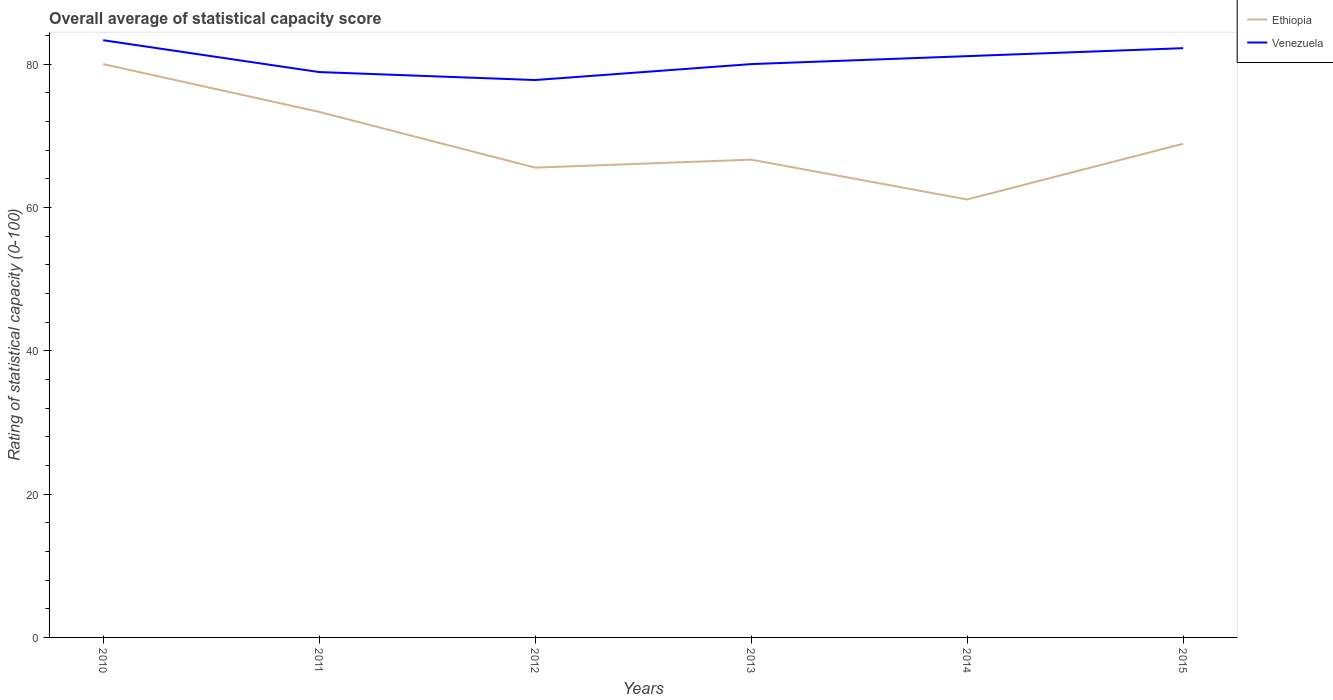Is the number of lines equal to the number of legend labels?
Offer a terse response. Yes. Across all years, what is the maximum rating of statistical capacity in Venezuela?
Provide a short and direct response. 77.78. In which year was the rating of statistical capacity in Ethiopia maximum?
Your answer should be compact. 2014. What is the total rating of statistical capacity in Ethiopia in the graph?
Offer a terse response. 12.22. What is the difference between the highest and the second highest rating of statistical capacity in Venezuela?
Provide a succinct answer. 5.56. How many lines are there?
Ensure brevity in your answer.  2. How many years are there in the graph?
Your answer should be compact. 6. What is the difference between two consecutive major ticks on the Y-axis?
Keep it short and to the point. 20. Are the values on the major ticks of Y-axis written in scientific E-notation?
Make the answer very short. No. How many legend labels are there?
Your response must be concise. 2. What is the title of the graph?
Provide a short and direct response. Overall average of statistical capacity score. Does "Kiribati" appear as one of the legend labels in the graph?
Your answer should be very brief. No. What is the label or title of the Y-axis?
Offer a very short reply. Rating of statistical capacity (0-100). What is the Rating of statistical capacity (0-100) in Ethiopia in 2010?
Your answer should be very brief. 80. What is the Rating of statistical capacity (0-100) of Venezuela in 2010?
Your answer should be very brief. 83.33. What is the Rating of statistical capacity (0-100) of Ethiopia in 2011?
Make the answer very short. 73.33. What is the Rating of statistical capacity (0-100) in Venezuela in 2011?
Your response must be concise. 78.89. What is the Rating of statistical capacity (0-100) in Ethiopia in 2012?
Offer a very short reply. 65.56. What is the Rating of statistical capacity (0-100) of Venezuela in 2012?
Provide a short and direct response. 77.78. What is the Rating of statistical capacity (0-100) in Ethiopia in 2013?
Make the answer very short. 66.67. What is the Rating of statistical capacity (0-100) in Venezuela in 2013?
Provide a short and direct response. 80. What is the Rating of statistical capacity (0-100) of Ethiopia in 2014?
Offer a very short reply. 61.11. What is the Rating of statistical capacity (0-100) in Venezuela in 2014?
Your answer should be very brief. 81.11. What is the Rating of statistical capacity (0-100) in Ethiopia in 2015?
Offer a terse response. 68.89. What is the Rating of statistical capacity (0-100) of Venezuela in 2015?
Offer a terse response. 82.22. Across all years, what is the maximum Rating of statistical capacity (0-100) in Venezuela?
Offer a terse response. 83.33. Across all years, what is the minimum Rating of statistical capacity (0-100) of Ethiopia?
Offer a very short reply. 61.11. Across all years, what is the minimum Rating of statistical capacity (0-100) of Venezuela?
Offer a very short reply. 77.78. What is the total Rating of statistical capacity (0-100) of Ethiopia in the graph?
Offer a very short reply. 415.56. What is the total Rating of statistical capacity (0-100) in Venezuela in the graph?
Make the answer very short. 483.33. What is the difference between the Rating of statistical capacity (0-100) in Ethiopia in 2010 and that in 2011?
Provide a succinct answer. 6.67. What is the difference between the Rating of statistical capacity (0-100) of Venezuela in 2010 and that in 2011?
Offer a terse response. 4.44. What is the difference between the Rating of statistical capacity (0-100) in Ethiopia in 2010 and that in 2012?
Give a very brief answer. 14.44. What is the difference between the Rating of statistical capacity (0-100) in Venezuela in 2010 and that in 2012?
Your answer should be compact. 5.56. What is the difference between the Rating of statistical capacity (0-100) of Ethiopia in 2010 and that in 2013?
Your answer should be very brief. 13.33. What is the difference between the Rating of statistical capacity (0-100) in Venezuela in 2010 and that in 2013?
Provide a short and direct response. 3.33. What is the difference between the Rating of statistical capacity (0-100) of Ethiopia in 2010 and that in 2014?
Provide a succinct answer. 18.89. What is the difference between the Rating of statistical capacity (0-100) in Venezuela in 2010 and that in 2014?
Ensure brevity in your answer.  2.22. What is the difference between the Rating of statistical capacity (0-100) in Ethiopia in 2010 and that in 2015?
Your answer should be compact. 11.11. What is the difference between the Rating of statistical capacity (0-100) of Ethiopia in 2011 and that in 2012?
Offer a terse response. 7.78. What is the difference between the Rating of statistical capacity (0-100) in Venezuela in 2011 and that in 2012?
Your response must be concise. 1.11. What is the difference between the Rating of statistical capacity (0-100) in Ethiopia in 2011 and that in 2013?
Your answer should be very brief. 6.67. What is the difference between the Rating of statistical capacity (0-100) in Venezuela in 2011 and that in 2013?
Offer a very short reply. -1.11. What is the difference between the Rating of statistical capacity (0-100) of Ethiopia in 2011 and that in 2014?
Your response must be concise. 12.22. What is the difference between the Rating of statistical capacity (0-100) in Venezuela in 2011 and that in 2014?
Your response must be concise. -2.22. What is the difference between the Rating of statistical capacity (0-100) of Ethiopia in 2011 and that in 2015?
Give a very brief answer. 4.44. What is the difference between the Rating of statistical capacity (0-100) of Venezuela in 2011 and that in 2015?
Ensure brevity in your answer.  -3.33. What is the difference between the Rating of statistical capacity (0-100) in Ethiopia in 2012 and that in 2013?
Offer a terse response. -1.11. What is the difference between the Rating of statistical capacity (0-100) in Venezuela in 2012 and that in 2013?
Your response must be concise. -2.22. What is the difference between the Rating of statistical capacity (0-100) of Ethiopia in 2012 and that in 2014?
Provide a short and direct response. 4.44. What is the difference between the Rating of statistical capacity (0-100) of Ethiopia in 2012 and that in 2015?
Provide a succinct answer. -3.33. What is the difference between the Rating of statistical capacity (0-100) in Venezuela in 2012 and that in 2015?
Make the answer very short. -4.44. What is the difference between the Rating of statistical capacity (0-100) of Ethiopia in 2013 and that in 2014?
Offer a very short reply. 5.56. What is the difference between the Rating of statistical capacity (0-100) of Venezuela in 2013 and that in 2014?
Your answer should be compact. -1.11. What is the difference between the Rating of statistical capacity (0-100) in Ethiopia in 2013 and that in 2015?
Your response must be concise. -2.22. What is the difference between the Rating of statistical capacity (0-100) in Venezuela in 2013 and that in 2015?
Provide a succinct answer. -2.22. What is the difference between the Rating of statistical capacity (0-100) of Ethiopia in 2014 and that in 2015?
Provide a succinct answer. -7.78. What is the difference between the Rating of statistical capacity (0-100) in Venezuela in 2014 and that in 2015?
Provide a succinct answer. -1.11. What is the difference between the Rating of statistical capacity (0-100) of Ethiopia in 2010 and the Rating of statistical capacity (0-100) of Venezuela in 2011?
Your answer should be very brief. 1.11. What is the difference between the Rating of statistical capacity (0-100) in Ethiopia in 2010 and the Rating of statistical capacity (0-100) in Venezuela in 2012?
Give a very brief answer. 2.22. What is the difference between the Rating of statistical capacity (0-100) in Ethiopia in 2010 and the Rating of statistical capacity (0-100) in Venezuela in 2014?
Provide a succinct answer. -1.11. What is the difference between the Rating of statistical capacity (0-100) in Ethiopia in 2010 and the Rating of statistical capacity (0-100) in Venezuela in 2015?
Ensure brevity in your answer.  -2.22. What is the difference between the Rating of statistical capacity (0-100) of Ethiopia in 2011 and the Rating of statistical capacity (0-100) of Venezuela in 2012?
Offer a terse response. -4.44. What is the difference between the Rating of statistical capacity (0-100) in Ethiopia in 2011 and the Rating of statistical capacity (0-100) in Venezuela in 2013?
Offer a terse response. -6.67. What is the difference between the Rating of statistical capacity (0-100) of Ethiopia in 2011 and the Rating of statistical capacity (0-100) of Venezuela in 2014?
Offer a very short reply. -7.78. What is the difference between the Rating of statistical capacity (0-100) of Ethiopia in 2011 and the Rating of statistical capacity (0-100) of Venezuela in 2015?
Your answer should be compact. -8.89. What is the difference between the Rating of statistical capacity (0-100) of Ethiopia in 2012 and the Rating of statistical capacity (0-100) of Venezuela in 2013?
Make the answer very short. -14.44. What is the difference between the Rating of statistical capacity (0-100) in Ethiopia in 2012 and the Rating of statistical capacity (0-100) in Venezuela in 2014?
Your answer should be compact. -15.56. What is the difference between the Rating of statistical capacity (0-100) in Ethiopia in 2012 and the Rating of statistical capacity (0-100) in Venezuela in 2015?
Your answer should be compact. -16.67. What is the difference between the Rating of statistical capacity (0-100) in Ethiopia in 2013 and the Rating of statistical capacity (0-100) in Venezuela in 2014?
Offer a terse response. -14.44. What is the difference between the Rating of statistical capacity (0-100) of Ethiopia in 2013 and the Rating of statistical capacity (0-100) of Venezuela in 2015?
Provide a succinct answer. -15.56. What is the difference between the Rating of statistical capacity (0-100) in Ethiopia in 2014 and the Rating of statistical capacity (0-100) in Venezuela in 2015?
Offer a very short reply. -21.11. What is the average Rating of statistical capacity (0-100) of Ethiopia per year?
Your response must be concise. 69.26. What is the average Rating of statistical capacity (0-100) of Venezuela per year?
Your answer should be very brief. 80.56. In the year 2011, what is the difference between the Rating of statistical capacity (0-100) in Ethiopia and Rating of statistical capacity (0-100) in Venezuela?
Offer a very short reply. -5.56. In the year 2012, what is the difference between the Rating of statistical capacity (0-100) of Ethiopia and Rating of statistical capacity (0-100) of Venezuela?
Ensure brevity in your answer.  -12.22. In the year 2013, what is the difference between the Rating of statistical capacity (0-100) in Ethiopia and Rating of statistical capacity (0-100) in Venezuela?
Offer a very short reply. -13.33. In the year 2014, what is the difference between the Rating of statistical capacity (0-100) of Ethiopia and Rating of statistical capacity (0-100) of Venezuela?
Give a very brief answer. -20. In the year 2015, what is the difference between the Rating of statistical capacity (0-100) in Ethiopia and Rating of statistical capacity (0-100) in Venezuela?
Your answer should be very brief. -13.33. What is the ratio of the Rating of statistical capacity (0-100) of Venezuela in 2010 to that in 2011?
Make the answer very short. 1.06. What is the ratio of the Rating of statistical capacity (0-100) of Ethiopia in 2010 to that in 2012?
Offer a very short reply. 1.22. What is the ratio of the Rating of statistical capacity (0-100) of Venezuela in 2010 to that in 2012?
Make the answer very short. 1.07. What is the ratio of the Rating of statistical capacity (0-100) in Ethiopia in 2010 to that in 2013?
Give a very brief answer. 1.2. What is the ratio of the Rating of statistical capacity (0-100) of Venezuela in 2010 to that in 2013?
Your answer should be very brief. 1.04. What is the ratio of the Rating of statistical capacity (0-100) in Ethiopia in 2010 to that in 2014?
Provide a succinct answer. 1.31. What is the ratio of the Rating of statistical capacity (0-100) of Venezuela in 2010 to that in 2014?
Your response must be concise. 1.03. What is the ratio of the Rating of statistical capacity (0-100) in Ethiopia in 2010 to that in 2015?
Your answer should be compact. 1.16. What is the ratio of the Rating of statistical capacity (0-100) in Venezuela in 2010 to that in 2015?
Provide a succinct answer. 1.01. What is the ratio of the Rating of statistical capacity (0-100) in Ethiopia in 2011 to that in 2012?
Provide a short and direct response. 1.12. What is the ratio of the Rating of statistical capacity (0-100) of Venezuela in 2011 to that in 2012?
Make the answer very short. 1.01. What is the ratio of the Rating of statistical capacity (0-100) of Venezuela in 2011 to that in 2013?
Provide a short and direct response. 0.99. What is the ratio of the Rating of statistical capacity (0-100) in Ethiopia in 2011 to that in 2014?
Ensure brevity in your answer.  1.2. What is the ratio of the Rating of statistical capacity (0-100) of Venezuela in 2011 to that in 2014?
Give a very brief answer. 0.97. What is the ratio of the Rating of statistical capacity (0-100) in Ethiopia in 2011 to that in 2015?
Provide a short and direct response. 1.06. What is the ratio of the Rating of statistical capacity (0-100) of Venezuela in 2011 to that in 2015?
Make the answer very short. 0.96. What is the ratio of the Rating of statistical capacity (0-100) of Ethiopia in 2012 to that in 2013?
Offer a terse response. 0.98. What is the ratio of the Rating of statistical capacity (0-100) of Venezuela in 2012 to that in 2013?
Give a very brief answer. 0.97. What is the ratio of the Rating of statistical capacity (0-100) in Ethiopia in 2012 to that in 2014?
Ensure brevity in your answer.  1.07. What is the ratio of the Rating of statistical capacity (0-100) of Venezuela in 2012 to that in 2014?
Offer a terse response. 0.96. What is the ratio of the Rating of statistical capacity (0-100) in Ethiopia in 2012 to that in 2015?
Ensure brevity in your answer.  0.95. What is the ratio of the Rating of statistical capacity (0-100) in Venezuela in 2012 to that in 2015?
Offer a terse response. 0.95. What is the ratio of the Rating of statistical capacity (0-100) in Ethiopia in 2013 to that in 2014?
Your response must be concise. 1.09. What is the ratio of the Rating of statistical capacity (0-100) of Venezuela in 2013 to that in 2014?
Your answer should be compact. 0.99. What is the ratio of the Rating of statistical capacity (0-100) in Ethiopia in 2014 to that in 2015?
Your response must be concise. 0.89. What is the ratio of the Rating of statistical capacity (0-100) in Venezuela in 2014 to that in 2015?
Your answer should be compact. 0.99. What is the difference between the highest and the second highest Rating of statistical capacity (0-100) in Venezuela?
Your response must be concise. 1.11. What is the difference between the highest and the lowest Rating of statistical capacity (0-100) of Ethiopia?
Give a very brief answer. 18.89. What is the difference between the highest and the lowest Rating of statistical capacity (0-100) in Venezuela?
Your answer should be compact. 5.56. 